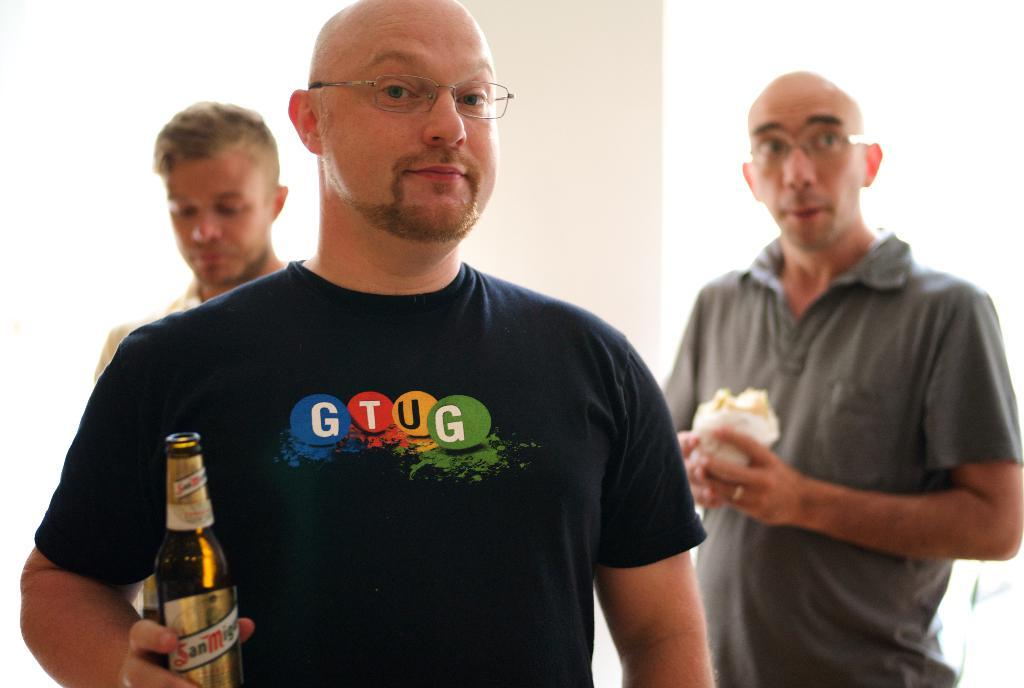How many people are in the image? There are three persons in the image. What is the front person holding in the image? The front person is holding a bottle. What can be observed about the front person's appearance? The front person is wearing glasses (specs). What is the second person wearing in the image? The second person is wearing a gray t-shirt. What is the second person holding in the image? The second person is holding a food item in his hand. What type of sleet can be seen falling in the image? There is no sleet present in the image; it is a picture of three persons with specific objects and clothing items. How far away is the letter from the third person in the image? There is no letter present in the image, so it is not possible to determine the distance between the third person and a letter. 